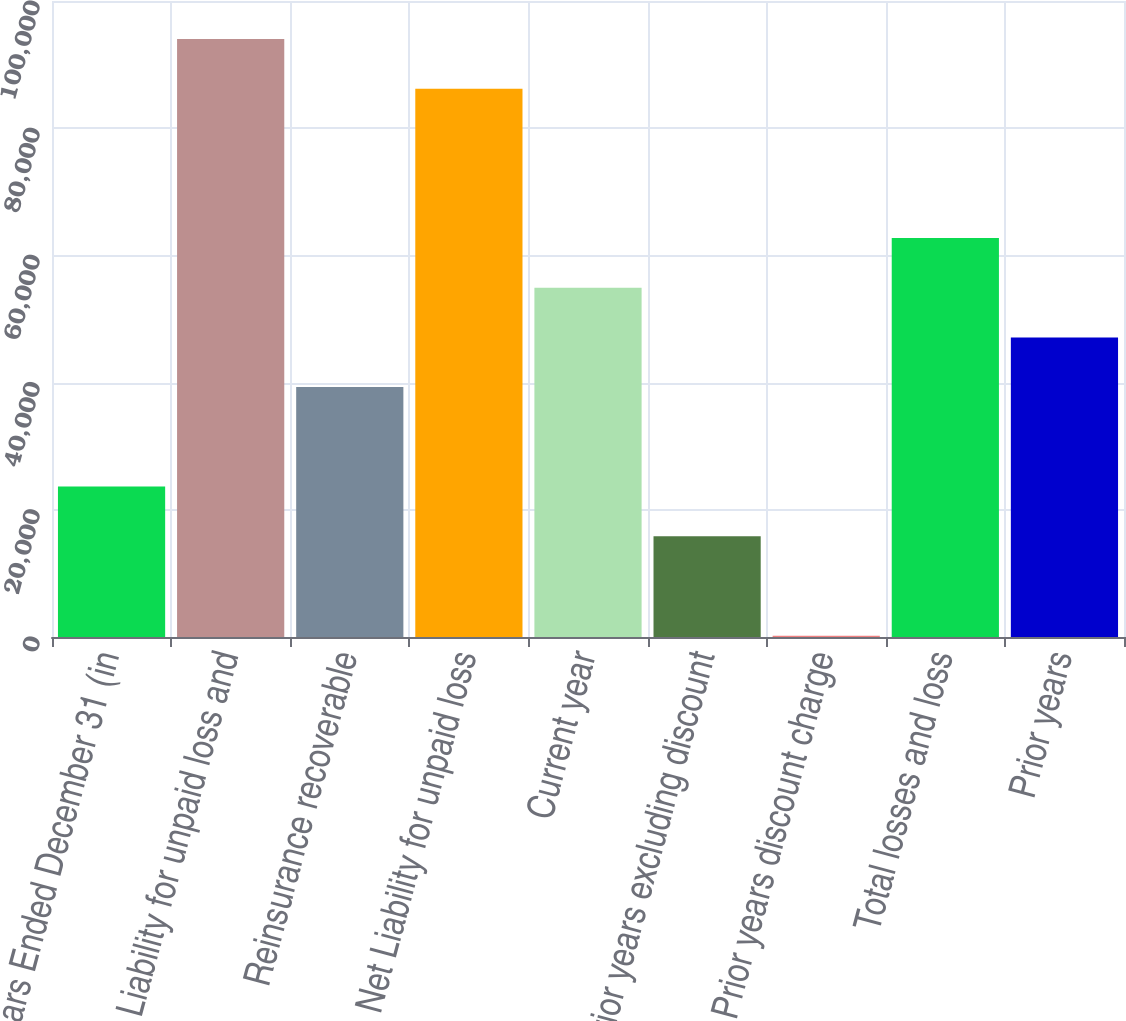Convert chart. <chart><loc_0><loc_0><loc_500><loc_500><bar_chart><fcel>Years Ended December 31 (in<fcel>Liability for unpaid loss and<fcel>Reinsurance recoverable<fcel>Net Liability for unpaid loss<fcel>Current year<fcel>Prior years excluding discount<fcel>Prior years discount charge<fcel>Total losses and loss<fcel>Prior years<nl><fcel>23648.8<fcel>94034.2<fcel>39290<fcel>86213.6<fcel>54931.2<fcel>15828.2<fcel>187<fcel>62751.8<fcel>47110.6<nl></chart> 